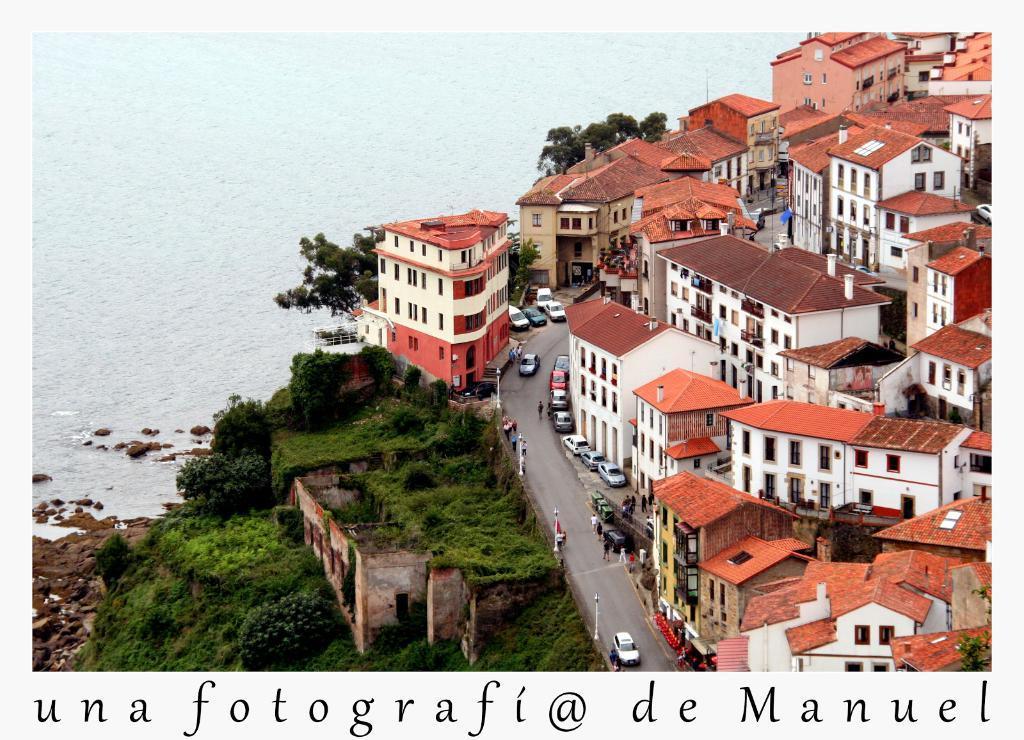How would you summarize this image in a sentence or two? On the right side of the image we can see some buildings and vehicles on the road. In the bottom left corner of the image we can see some trees. At the top of the image we can see water. 